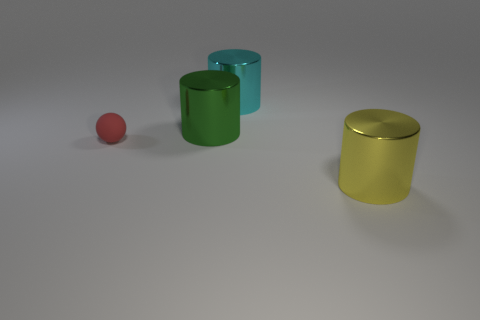Are there any other things that are the same material as the sphere?
Keep it short and to the point. No. What number of things are large cylinders on the right side of the green metallic cylinder or red spheres left of the large green metallic cylinder?
Offer a very short reply. 3. There is a green object that is the same size as the yellow metal cylinder; what shape is it?
Your answer should be very brief. Cylinder. Are there any big yellow objects that have the same shape as the red thing?
Provide a short and direct response. No. Are there fewer small gray blocks than cyan shiny objects?
Make the answer very short. Yes. There is a cylinder that is in front of the tiny red matte object; is its size the same as the cylinder on the left side of the large cyan metal object?
Your answer should be very brief. Yes. How many objects are either small red matte spheres or yellow things?
Make the answer very short. 2. What size is the object to the left of the green cylinder?
Keep it short and to the point. Small. There is a large metallic thing left of the big object that is behind the big green shiny cylinder; what number of tiny red spheres are to the right of it?
Your answer should be compact. 0. How many things are to the right of the small red thing and in front of the large cyan shiny cylinder?
Make the answer very short. 2. 